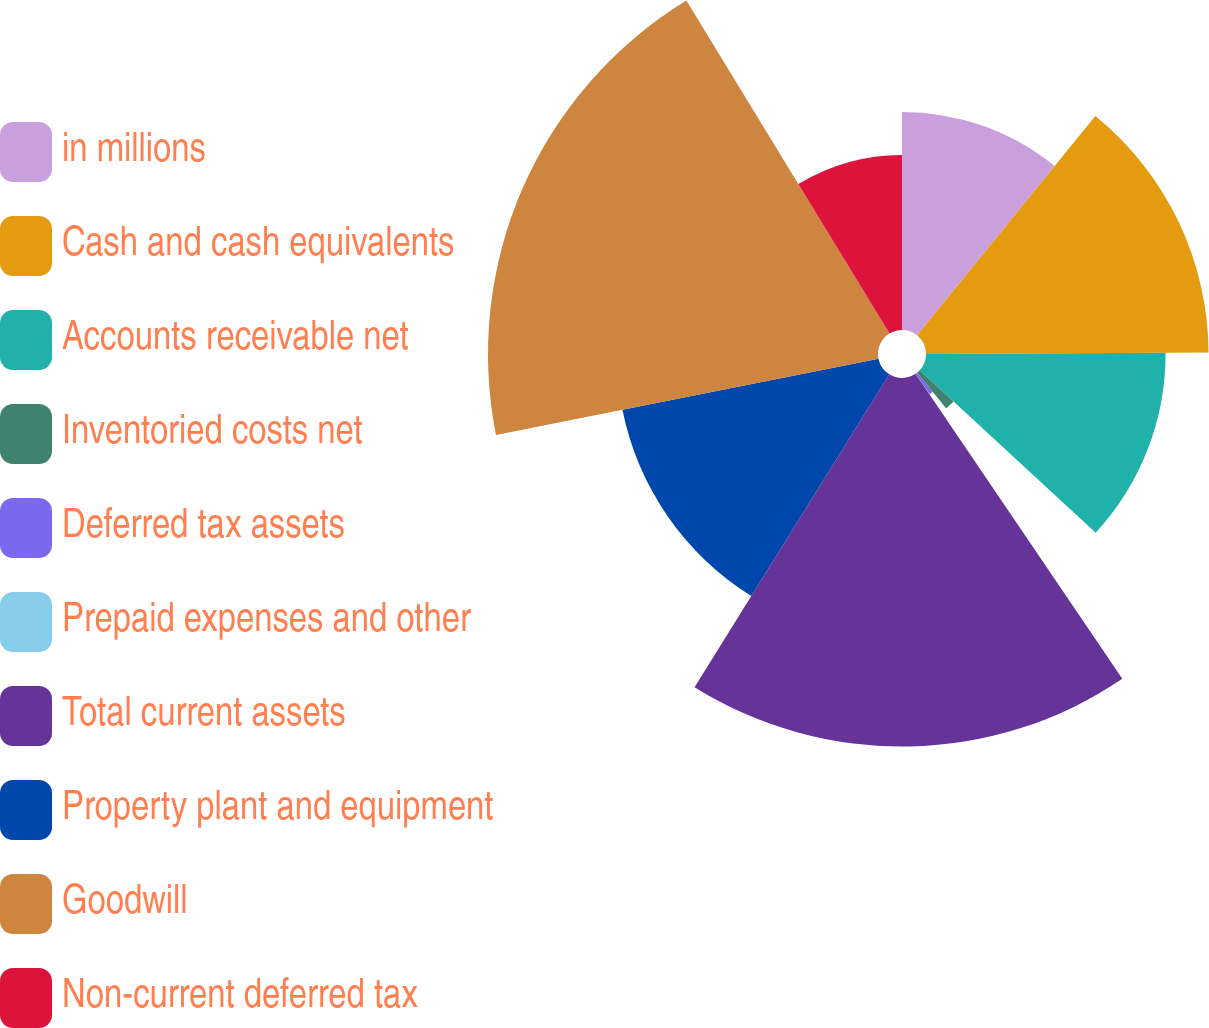Convert chart to OTSL. <chart><loc_0><loc_0><loc_500><loc_500><pie_chart><fcel>in millions<fcel>Cash and cash equivalents<fcel>Accounts receivable net<fcel>Inventoried costs net<fcel>Deferred tax assets<fcel>Prepaid expenses and other<fcel>Total current assets<fcel>Property plant and equipment<fcel>Goodwill<fcel>Non-current deferred tax<nl><fcel>10.86%<fcel>14.07%<fcel>11.93%<fcel>2.29%<fcel>1.22%<fcel>0.15%<fcel>18.35%<fcel>13.0%<fcel>19.42%<fcel>8.72%<nl></chart> 